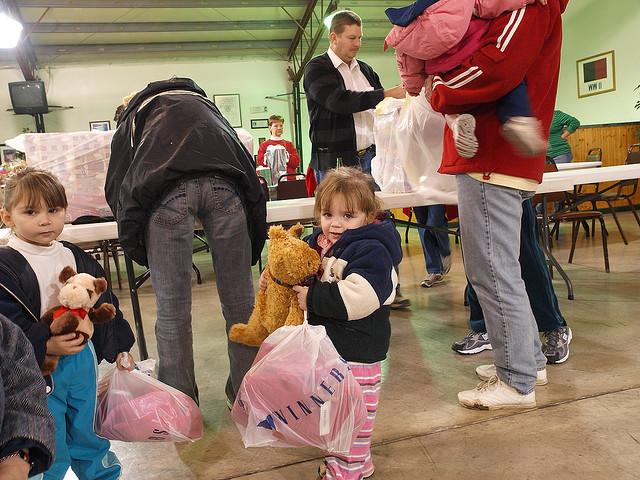Who has no shoes on?
Quick response, please. No one. What are the girls holding?
Give a very brief answer. Stuffed animals. What is the man in the red jacket holding?
Short answer required. Baby. What are the children carrying on their back?
Quick response, please. Coats. 